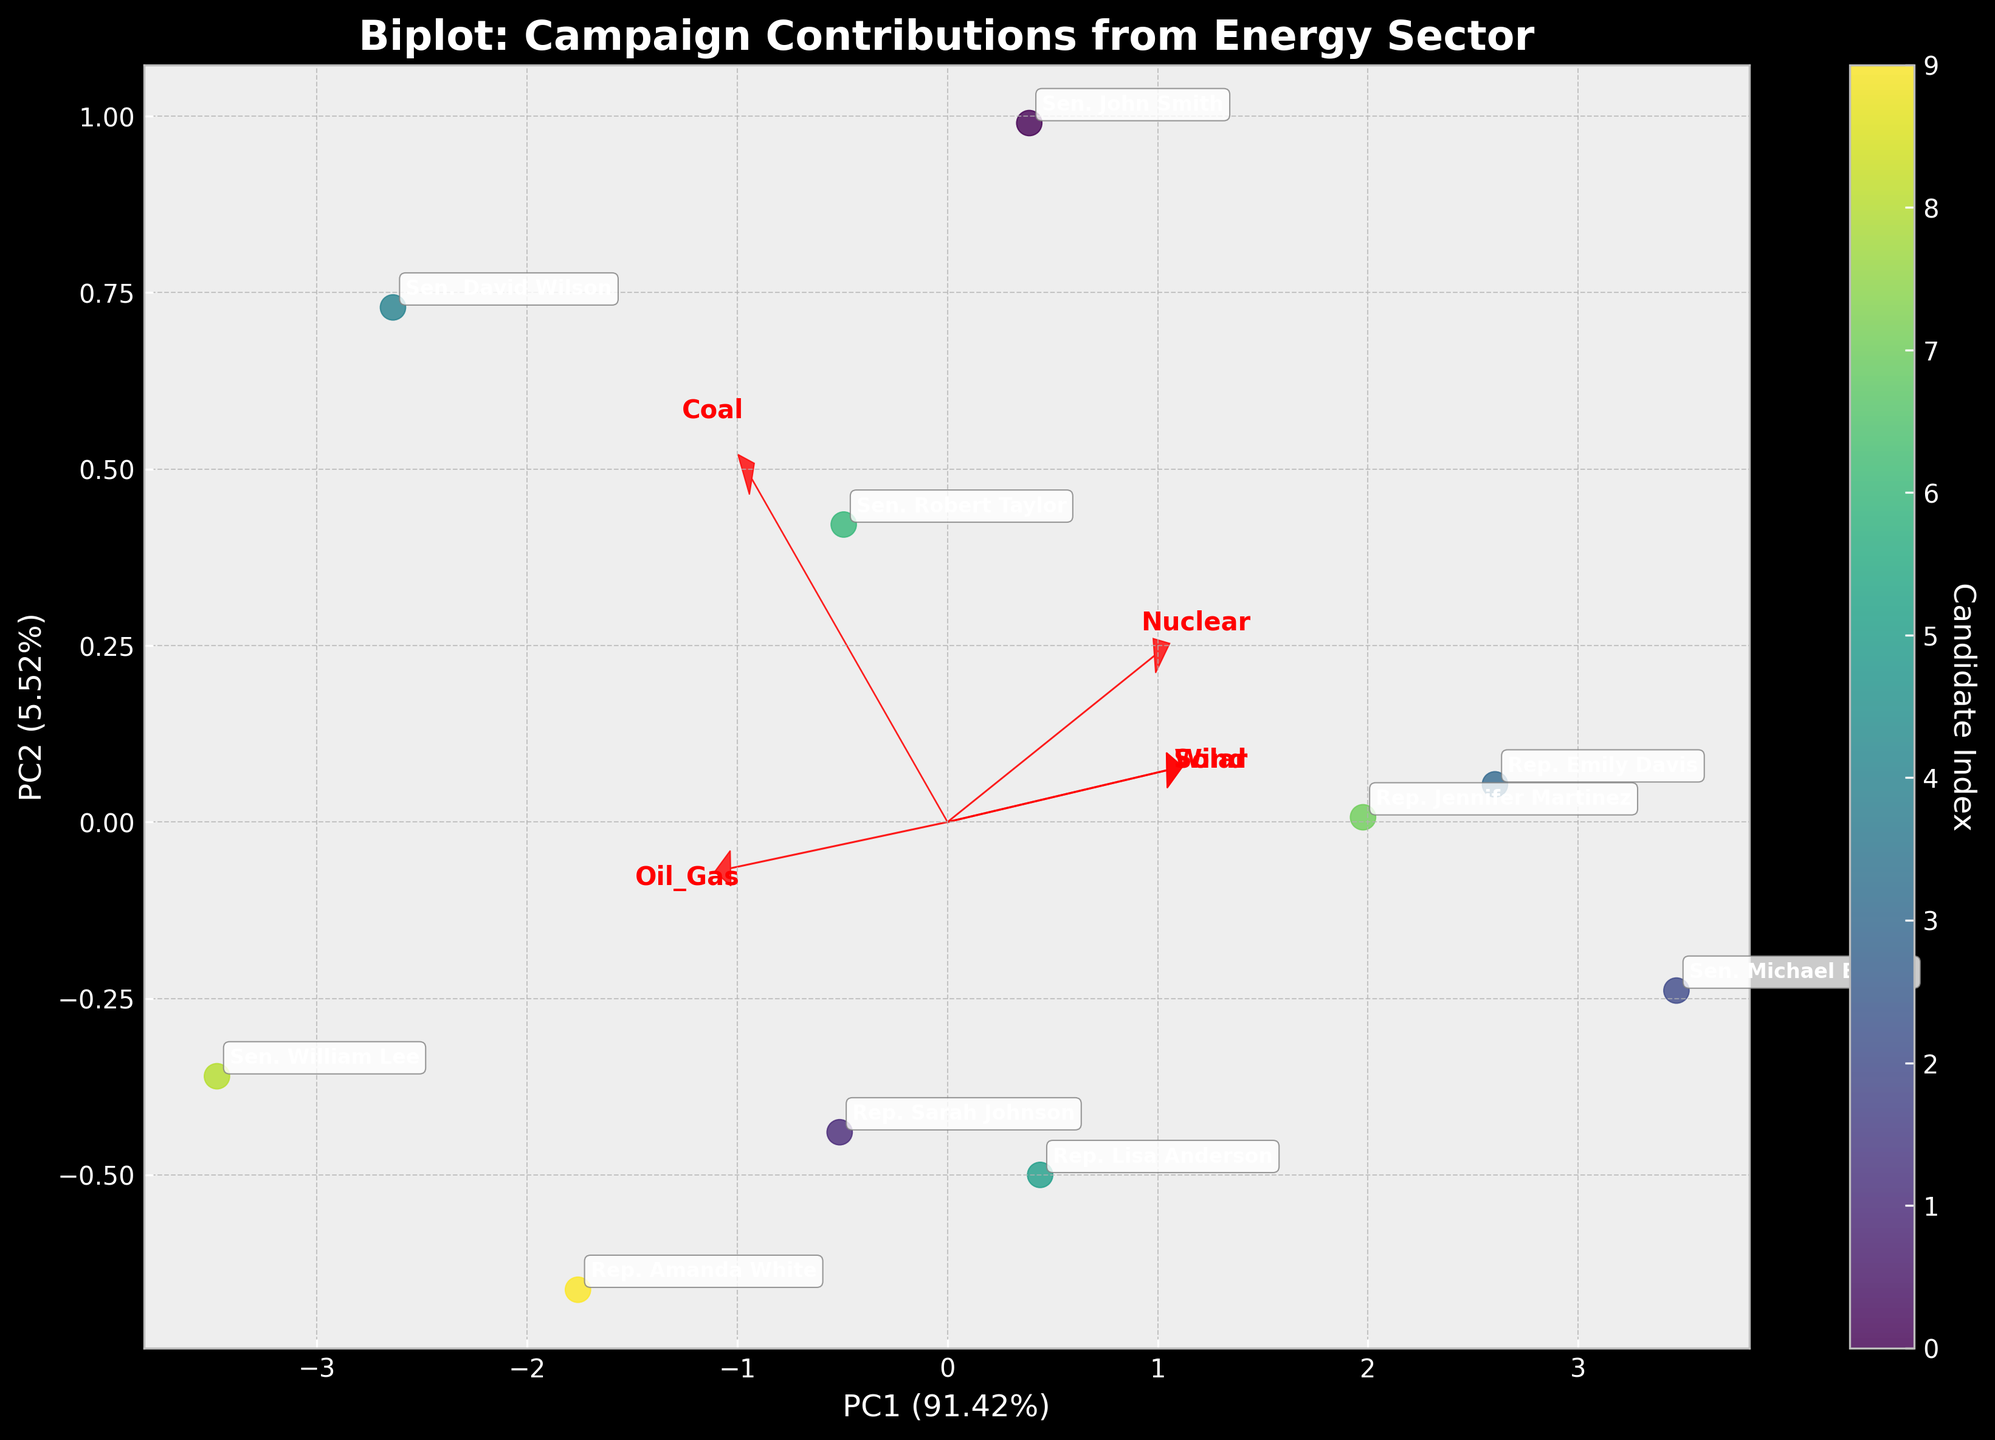What is the title of the plot? The title is written at the top of the plot to give an overview of the data visualized. By reading the text at the top, one can identify the purpose of the graph.
Answer: Biplot: Campaign Contributions from Energy Sector Which candidate received the highest contribution from coal companies? Look for the point on the graph that is furthest along the direction of the coal vector (red arrow). The candidate's label next to that point indicates who received the highest contribution.
Answer: Sen. David Wilson How do contributions from nuclear companies compare between Sen. John Smith and Rep. Jennifer Martinez? Compare the positions of the two candidates relative to the direction of the nuclear vector. The candidate closer to or more aligned with this direction received higher contributions.
Answer: Rep. Jennifer Martinez received more Does the figure indicate a correlation between contributions from oil & gas companies and coal companies? If the vectors for oil & gas and coal contributions are pointed in similar directions, it indicates a positive correlation. If they are orthogonal or oppositely directed, it indicates no correlation or negative correlation respectively.
Answer: Yes, there is a positive correlation What are the directions and magnitude of the loadings for the solar and wind contributions? Check the arrows representing solar and wind contributions. The direction indicates the correlation with the principal components, while the length represents the magnitude of their influence.
Answer: Solar is to the upper left, and wind is towards the left; both are shorter, indicating lesser influence Which principal component explains more of the variance in the data? Look at the axis labels for PC1 and PC2. The percentages next to each PC indicate how much variance they explain.
Answer: PC1 explains more variance Are the contributions from wind energy more varied compared to nuclear energy? Check the spread of scores along the direction of the wind vector against the spread along the nuclear vector. Greater spread indicates more variation.
Answer: Wind contributions are less varied than nuclear What is the association between Rep. Amanda White's contributions and solar and wind companies? Look at the position of Rep. Amanda White in relation to the solar and wind vectors. If the candidate's point is closer to these vectors, it indicates higher contributions.
Answer: Relatively low contributions Which candidates have similar campaign contribution profiles? Candidates who are located close to each other on the biplot have similar profiles regarding contributions from different energy sectors. Look for clusters of points.
Answer: Rep. Sarah Johnson and Sen. Robert Taylor Can you identify any outliers among the candidates based on the campaign contributions? Check for points that are isolated from the main cluster of candidates. Outliers will be those situated further away from others.
Answer: Sen. David Wilson 